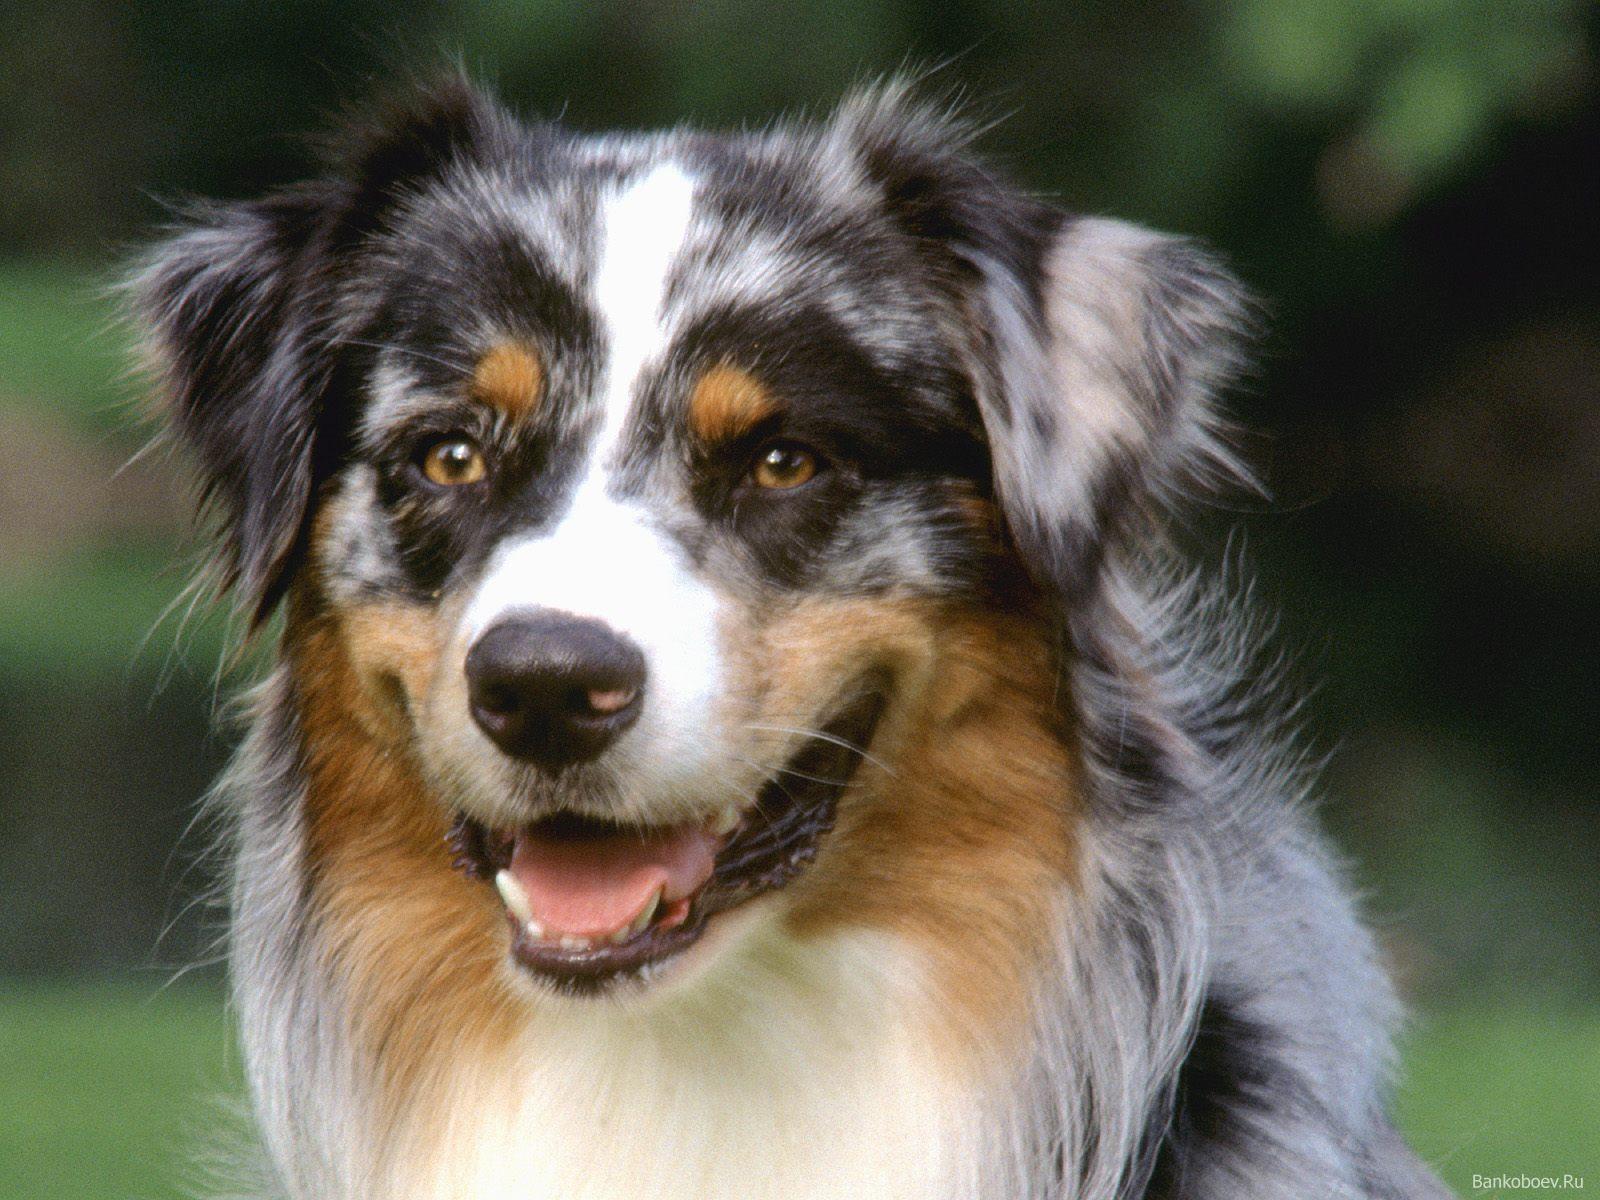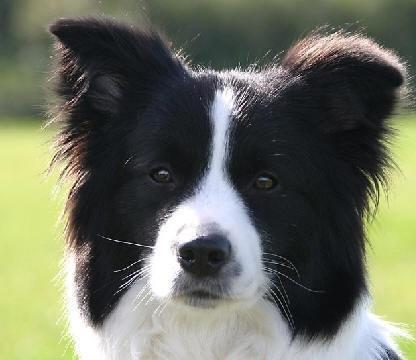The first image is the image on the left, the second image is the image on the right. For the images displayed, is the sentence "The coat of the dog on the right is black and white only." factually correct? Answer yes or no. Yes. 